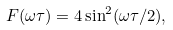Convert formula to latex. <formula><loc_0><loc_0><loc_500><loc_500>F ( \omega \tau ) = 4 \sin ^ { 2 } ( \omega \tau / 2 ) ,</formula> 